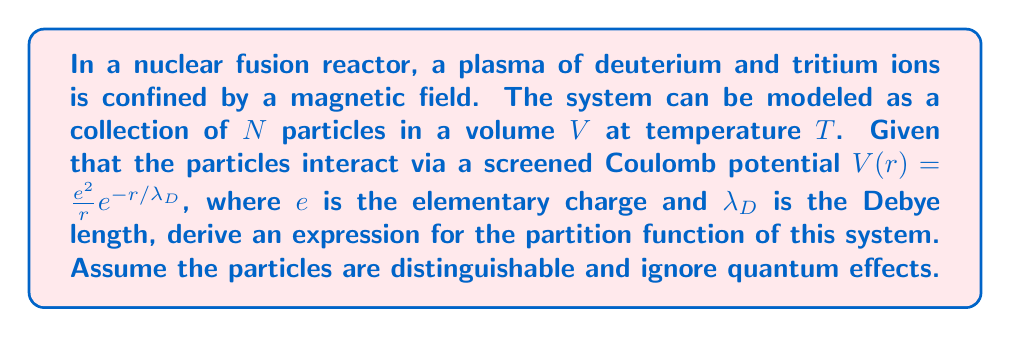Help me with this question. To compute the partition function for this system of interacting particles in a nuclear plasma, we'll follow these steps:

1) The partition function for a system of $N$ distinguishable particles is given by:

   $$Z = \frac{1}{N!}\left(\int e^{-\beta H(p,q)} dp dq\right)^N$$

   where $\beta = \frac{1}{k_B T}$, $k_B$ is Boltzmann's constant, and $H(p,q)$ is the Hamiltonian of the system.

2) The Hamiltonian for our system can be written as:

   $$H(p,q) = \sum_{i=1}^N \frac{p_i^2}{2m} + \frac{1}{2}\sum_{i\neq j} V(r_{ij})$$

   where $m$ is the mass of each particle, $p_i$ is the momentum of particle $i$, and $r_{ij}$ is the distance between particles $i$ and $j$.

3) Substituting this into our partition function:

   $$Z = \frac{1}{N!}\left(\int e^{-\beta(\sum_{i=1}^N \frac{p_i^2}{2m} + \frac{1}{2}\sum_{i\neq j} V(r_{ij}))} dp dq\right)^N$$

4) We can separate the kinetic and potential parts:

   $$Z = \frac{1}{N!}\left(\int e^{-\beta\sum_{i=1}^N \frac{p_i^2}{2m}} dp \int e^{-\beta\frac{1}{2}\sum_{i\neq j} V(r_{ij})} dq\right)^N$$

5) The kinetic part is straightforward to integrate:

   $$\int e^{-\beta\sum_{i=1}^N \frac{p_i^2}{2m}} dp = \left(\frac{2\pi m}{\beta}\right)^{3N/2}$$

6) For the potential part, we need to use the screened Coulomb potential:

   $$V(r) = \frac{e^2}{r}e^{-r/\lambda_D}$$

7) The potential energy integral is complex and cannot be solved analytically in general. We can express it as:

   $$\int e^{-\beta\frac{1}{2}\sum_{i\neq j} V(r_{ij})} dq = V^N e^{-\beta F_{ex}}$$

   where $F_{ex}$ is the excess free energy due to interactions.

8) Combining all parts, our partition function becomes:

   $$Z = \frac{1}{N!}\left(\left(\frac{2\pi m}{\beta}\right)^{3/2}V e^{-\beta F_{ex}/N}\right)^N$$

9) This can be simplified to:

   $$Z = \frac{1}{N!}\left(\frac{2\pi m}{\beta}\right)^{3N/2}V^N e^{-\beta F_{ex}}$$

This is the partition function for our system of interacting particles in a nuclear plasma.
Answer: $Z = \frac{1}{N!}\left(\frac{2\pi m}{\beta}\right)^{3N/2}V^N e^{-\beta F_{ex}}$ 